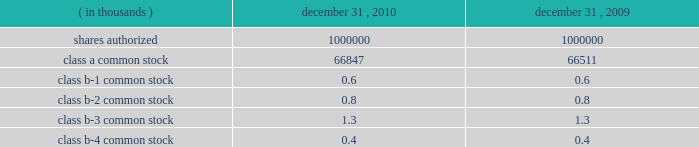Interest rate derivatives .
In connection with the issuance of floating rate debt in august and october 2008 , the company entered into three interest rate swap contracts , designated as cash flow hedges , for purposes of hedging against a change in interest payments due to fluctuations in the underlying benchmark rate .
In december 2010 , the company approved a plan to refinance the term loan in january 2011 resulting in an $ 8.6 million loss on derivative instruments as a result of ineffectiveness on the associated interest rate swap contract .
To mitigate counterparty credit risk , the interest rate swap contracts required collateralization by both counterparties for the swaps 2019 aggregate net fair value during their respective terms .
Collateral was maintained in the form of cash and adjusted on a daily basis .
In february 2010 , the company entered into a forward starting interest rate swap contract , designated as a cash flow hedge , for purposes of hedging against a change in interest payments due to fluctuations in the underlying benchmark rate between the date of the swap and the forecasted issuance of fixed rate debt in march 2010 .
The swap was highly effective .
Foreign currency derivatives .
In connection with its purchase of bm&fbovespa stock in february 2008 , cme group purchased a put option to hedge against changes in the fair value of bm&fbovespa stock resulting from foreign currency rate fluctuations between the u.s .
Dollar and the brazilian real ( brl ) beyond the option 2019s exercise price .
Lehman brothers special financing inc .
( lbsf ) was the sole counterparty to this option contract .
On september 15 , 2008 , lehman brothers holdings inc .
( lehman ) filed for protection under chapter 11 of the united states bankruptcy code .
The bankruptcy filing of lehman was an event of default that gave the company the right to immediately terminate the put option agreement with lbsf .
In march 2010 , the company recognized a $ 6.0 million gain on derivative instruments as a result of a settlement from the lehman bankruptcy proceedings .
21 .
Capital stock shares outstanding .
The table presents information regarding capital stock: .
Cme group has no shares of preferred stock issued and outstanding .
Associated trading rights .
Members of cme , cbot , nymex and comex own or lease trading rights which entitle them to access the trading floors , discounts on trading fees and the right to vote on certain exchange matters as provided for by the rules of the particular exchange and cme group 2019s or the subsidiaries 2019 organizational documents .
Each class of cme group class b common stock is associated with a membership in a specific division for trading at cme .
A cme trading right is a separate asset that is not part of or evidenced by the associated share of class b common stock of cme group .
The class b common stock of cme group is intended only to ensure that the class b shareholders of cme group retain rights with respect to representation on the board of directors and approval rights with respect to the core rights described below .
Trading rights at cbot are evidenced by class b memberships in cbot , at nymex by class a memberships in nymex and at comex by comex division memberships in comex .
Members of the cbot , nymex and comex exchanges do not have any rights to elect members of the board of directors and are not entitled to receive dividends or other distributions on their memberships .
The company is , however , required to have at least 10 cbot directors ( as defined by its bylaws ) until its 2012 annual meeting. .
For 2010 , what were the total number of shares of common stock outstanding , in thousands? 
Computations: (((66847 + 0.6) + 0.8) + 1.3)
Answer: 66849.7. 